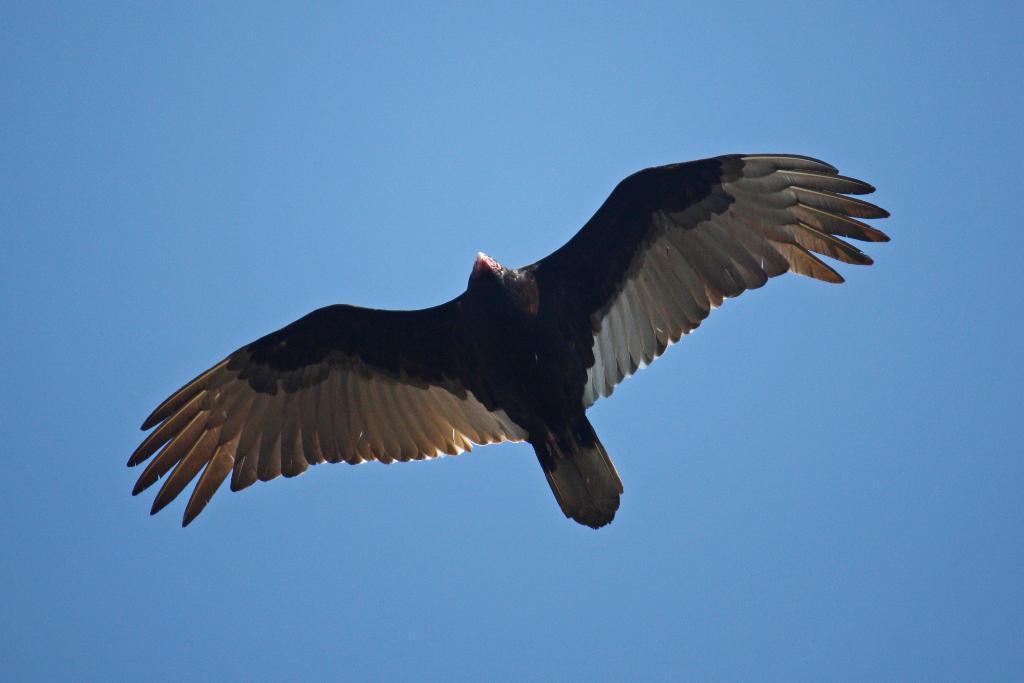Can you describe this image briefly? In this picture we can see a brown and white color big eagle flying in the sky. 